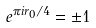<formula> <loc_0><loc_0><loc_500><loc_500>e ^ { \pi i r _ { 0 } / 4 } = \pm 1</formula> 